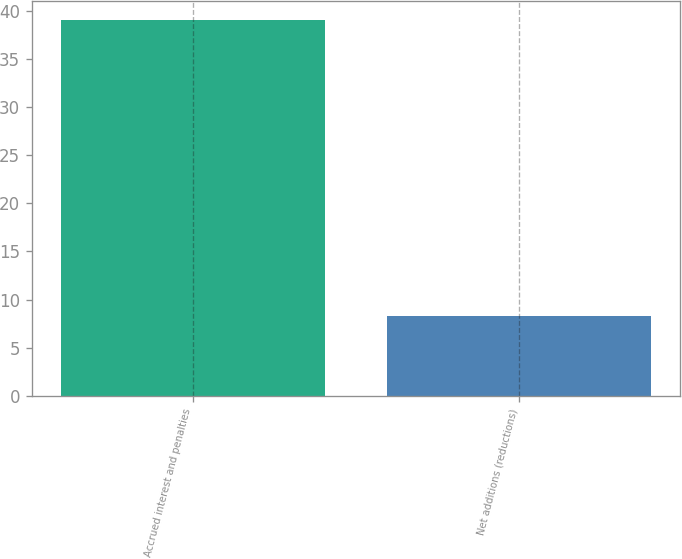Convert chart to OTSL. <chart><loc_0><loc_0><loc_500><loc_500><bar_chart><fcel>Accrued interest and penalties<fcel>Net additions (reductions)<nl><fcel>39<fcel>8.3<nl></chart> 